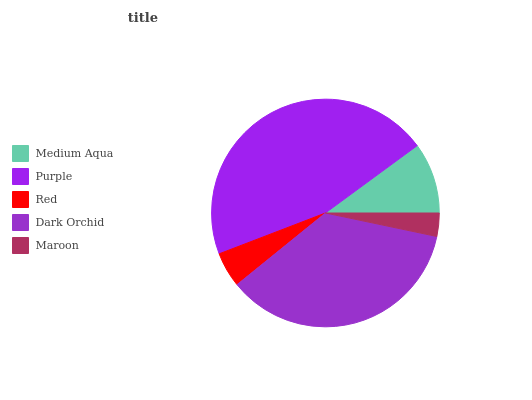Is Maroon the minimum?
Answer yes or no. Yes. Is Purple the maximum?
Answer yes or no. Yes. Is Red the minimum?
Answer yes or no. No. Is Red the maximum?
Answer yes or no. No. Is Purple greater than Red?
Answer yes or no. Yes. Is Red less than Purple?
Answer yes or no. Yes. Is Red greater than Purple?
Answer yes or no. No. Is Purple less than Red?
Answer yes or no. No. Is Medium Aqua the high median?
Answer yes or no. Yes. Is Medium Aqua the low median?
Answer yes or no. Yes. Is Purple the high median?
Answer yes or no. No. Is Dark Orchid the low median?
Answer yes or no. No. 